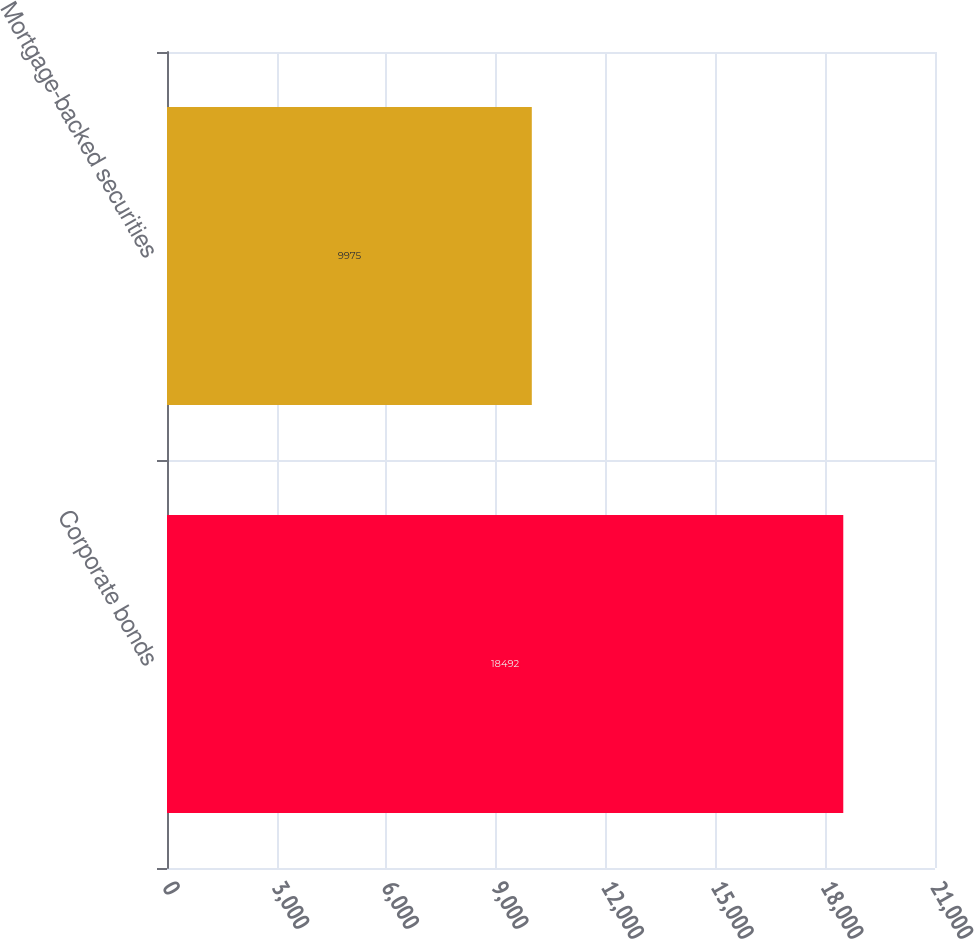<chart> <loc_0><loc_0><loc_500><loc_500><bar_chart><fcel>Corporate bonds<fcel>Mortgage-backed securities<nl><fcel>18492<fcel>9975<nl></chart> 